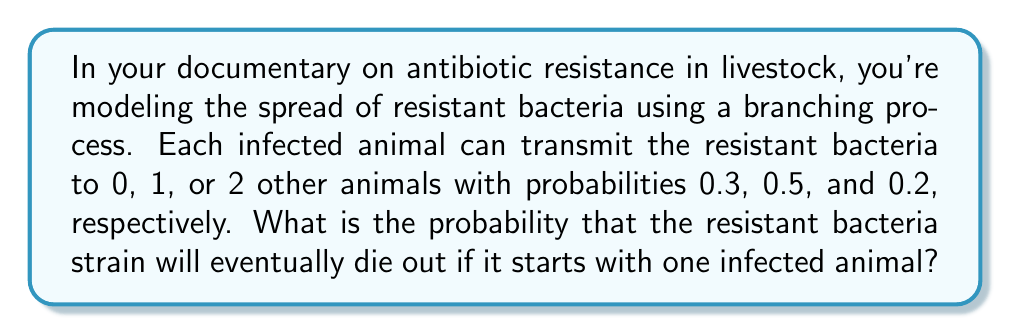Give your solution to this math problem. To solve this problem, we'll use the theory of branching processes:

1) Let's define $q$ as the probability of eventual extinction starting from one infected animal.

2) The probability generating function (PGF) for this branching process is:
   $$f(s) = 0.3 + 0.5s + 0.2s^2$$

3) According to the theory of branching processes, $q$ is the smallest non-negative root of the equation $s = f(s)$.

4) So, we need to solve:
   $$s = 0.3 + 0.5s + 0.2s^2$$

5) Rearranging the equation:
   $$0.2s^2 + 0.5s - 0.7 = 0$$

6) This is a quadratic equation. We can solve it using the quadratic formula:
   $$s = \frac{-b \pm \sqrt{b^2 - 4ac}}{2a}$$
   where $a = 0.2$, $b = 0.5$, and $c = -0.7$

7) Plugging in these values:
   $$s = \frac{-0.5 \pm \sqrt{0.5^2 - 4(0.2)(-0.7)}}{2(0.2)}$$

8) Simplifying:
   $$s = \frac{-0.5 \pm \sqrt{0.25 + 0.56}}{0.4} = \frac{-0.5 \pm \sqrt{0.81}}{0.4} = \frac{-0.5 \pm 0.9}{0.4}$$

9) This gives us two solutions:
   $$s_1 = \frac{-0.5 + 0.9}{0.4} = 1$$
   $$s_2 = \frac{-0.5 - 0.9}{0.4} = -3.5$$

10) Since we're looking for a probability, we choose the smaller non-negative root, which is $s_2 = 1$.

Therefore, the probability of eventual extinction is 1, meaning the resistant bacteria strain will eventually die out with certainty.
Answer: 1 